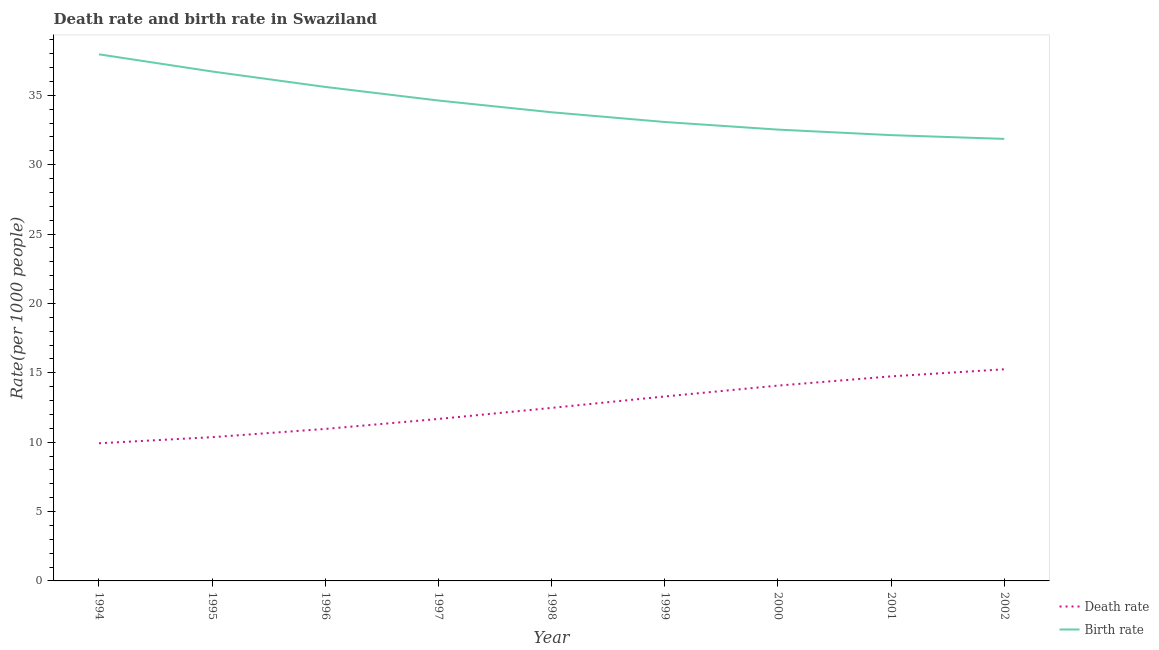How many different coloured lines are there?
Keep it short and to the point. 2. What is the death rate in 2002?
Offer a very short reply. 15.25. Across all years, what is the maximum birth rate?
Keep it short and to the point. 37.95. Across all years, what is the minimum birth rate?
Your answer should be very brief. 31.86. In which year was the birth rate maximum?
Your answer should be compact. 1994. In which year was the birth rate minimum?
Your response must be concise. 2002. What is the total birth rate in the graph?
Make the answer very short. 308.24. What is the difference between the death rate in 1996 and that in 1997?
Your response must be concise. -0.72. What is the difference between the death rate in 1996 and the birth rate in 1995?
Offer a very short reply. -25.76. What is the average death rate per year?
Offer a terse response. 12.53. In the year 1996, what is the difference between the birth rate and death rate?
Keep it short and to the point. 24.65. What is the ratio of the death rate in 1996 to that in 1998?
Your answer should be compact. 0.88. Is the difference between the birth rate in 1995 and 1997 greater than the difference between the death rate in 1995 and 1997?
Make the answer very short. Yes. What is the difference between the highest and the second highest death rate?
Offer a very short reply. 0.51. What is the difference between the highest and the lowest birth rate?
Your answer should be very brief. 6.09. Is the birth rate strictly greater than the death rate over the years?
Offer a very short reply. Yes. How many lines are there?
Keep it short and to the point. 2. Are the values on the major ticks of Y-axis written in scientific E-notation?
Provide a succinct answer. No. How many legend labels are there?
Give a very brief answer. 2. What is the title of the graph?
Your answer should be compact. Death rate and birth rate in Swaziland. What is the label or title of the Y-axis?
Offer a terse response. Rate(per 1000 people). What is the Rate(per 1000 people) of Death rate in 1994?
Your answer should be compact. 9.92. What is the Rate(per 1000 people) of Birth rate in 1994?
Ensure brevity in your answer.  37.95. What is the Rate(per 1000 people) in Death rate in 1995?
Ensure brevity in your answer.  10.36. What is the Rate(per 1000 people) of Birth rate in 1995?
Offer a very short reply. 36.71. What is the Rate(per 1000 people) of Death rate in 1996?
Ensure brevity in your answer.  10.95. What is the Rate(per 1000 people) in Birth rate in 1996?
Give a very brief answer. 35.6. What is the Rate(per 1000 people) of Death rate in 1997?
Provide a short and direct response. 11.67. What is the Rate(per 1000 people) in Birth rate in 1997?
Your response must be concise. 34.62. What is the Rate(per 1000 people) in Death rate in 1998?
Offer a terse response. 12.47. What is the Rate(per 1000 people) in Birth rate in 1998?
Provide a short and direct response. 33.77. What is the Rate(per 1000 people) in Death rate in 1999?
Provide a short and direct response. 13.29. What is the Rate(per 1000 people) in Birth rate in 1999?
Keep it short and to the point. 33.07. What is the Rate(per 1000 people) in Death rate in 2000?
Make the answer very short. 14.08. What is the Rate(per 1000 people) of Birth rate in 2000?
Ensure brevity in your answer.  32.52. What is the Rate(per 1000 people) in Death rate in 2001?
Make the answer very short. 14.74. What is the Rate(per 1000 people) in Birth rate in 2001?
Provide a short and direct response. 32.13. What is the Rate(per 1000 people) of Death rate in 2002?
Your response must be concise. 15.25. What is the Rate(per 1000 people) of Birth rate in 2002?
Your answer should be very brief. 31.86. Across all years, what is the maximum Rate(per 1000 people) of Death rate?
Make the answer very short. 15.25. Across all years, what is the maximum Rate(per 1000 people) of Birth rate?
Provide a succinct answer. 37.95. Across all years, what is the minimum Rate(per 1000 people) of Death rate?
Your response must be concise. 9.92. Across all years, what is the minimum Rate(per 1000 people) in Birth rate?
Offer a terse response. 31.86. What is the total Rate(per 1000 people) in Death rate in the graph?
Give a very brief answer. 112.74. What is the total Rate(per 1000 people) of Birth rate in the graph?
Offer a terse response. 308.24. What is the difference between the Rate(per 1000 people) of Death rate in 1994 and that in 1995?
Provide a succinct answer. -0.44. What is the difference between the Rate(per 1000 people) in Birth rate in 1994 and that in 1995?
Offer a terse response. 1.24. What is the difference between the Rate(per 1000 people) of Death rate in 1994 and that in 1996?
Give a very brief answer. -1.03. What is the difference between the Rate(per 1000 people) in Birth rate in 1994 and that in 1996?
Keep it short and to the point. 2.35. What is the difference between the Rate(per 1000 people) in Death rate in 1994 and that in 1997?
Give a very brief answer. -1.75. What is the difference between the Rate(per 1000 people) in Birth rate in 1994 and that in 1997?
Your response must be concise. 3.33. What is the difference between the Rate(per 1000 people) in Death rate in 1994 and that in 1998?
Keep it short and to the point. -2.55. What is the difference between the Rate(per 1000 people) in Birth rate in 1994 and that in 1998?
Give a very brief answer. 4.18. What is the difference between the Rate(per 1000 people) in Death rate in 1994 and that in 1999?
Ensure brevity in your answer.  -3.37. What is the difference between the Rate(per 1000 people) in Birth rate in 1994 and that in 1999?
Give a very brief answer. 4.88. What is the difference between the Rate(per 1000 people) of Death rate in 1994 and that in 2000?
Offer a very short reply. -4.16. What is the difference between the Rate(per 1000 people) of Birth rate in 1994 and that in 2000?
Your answer should be compact. 5.43. What is the difference between the Rate(per 1000 people) of Death rate in 1994 and that in 2001?
Provide a succinct answer. -4.82. What is the difference between the Rate(per 1000 people) in Birth rate in 1994 and that in 2001?
Your answer should be very brief. 5.82. What is the difference between the Rate(per 1000 people) in Death rate in 1994 and that in 2002?
Make the answer very short. -5.33. What is the difference between the Rate(per 1000 people) in Birth rate in 1994 and that in 2002?
Give a very brief answer. 6.09. What is the difference between the Rate(per 1000 people) in Death rate in 1995 and that in 1996?
Make the answer very short. -0.59. What is the difference between the Rate(per 1000 people) in Birth rate in 1995 and that in 1996?
Your answer should be compact. 1.11. What is the difference between the Rate(per 1000 people) of Death rate in 1995 and that in 1997?
Your response must be concise. -1.31. What is the difference between the Rate(per 1000 people) of Birth rate in 1995 and that in 1997?
Offer a terse response. 2.09. What is the difference between the Rate(per 1000 people) of Death rate in 1995 and that in 1998?
Ensure brevity in your answer.  -2.11. What is the difference between the Rate(per 1000 people) in Birth rate in 1995 and that in 1998?
Your answer should be compact. 2.94. What is the difference between the Rate(per 1000 people) in Death rate in 1995 and that in 1999?
Offer a terse response. -2.94. What is the difference between the Rate(per 1000 people) of Birth rate in 1995 and that in 1999?
Keep it short and to the point. 3.64. What is the difference between the Rate(per 1000 people) in Death rate in 1995 and that in 2000?
Provide a succinct answer. -3.72. What is the difference between the Rate(per 1000 people) of Birth rate in 1995 and that in 2000?
Your answer should be very brief. 4.19. What is the difference between the Rate(per 1000 people) in Death rate in 1995 and that in 2001?
Provide a short and direct response. -4.38. What is the difference between the Rate(per 1000 people) of Birth rate in 1995 and that in 2001?
Keep it short and to the point. 4.58. What is the difference between the Rate(per 1000 people) in Death rate in 1995 and that in 2002?
Ensure brevity in your answer.  -4.89. What is the difference between the Rate(per 1000 people) in Birth rate in 1995 and that in 2002?
Your answer should be compact. 4.86. What is the difference between the Rate(per 1000 people) in Death rate in 1996 and that in 1997?
Offer a very short reply. -0.72. What is the difference between the Rate(per 1000 people) of Birth rate in 1996 and that in 1997?
Offer a very short reply. 0.98. What is the difference between the Rate(per 1000 people) in Death rate in 1996 and that in 1998?
Provide a short and direct response. -1.52. What is the difference between the Rate(per 1000 people) of Birth rate in 1996 and that in 1998?
Your answer should be compact. 1.83. What is the difference between the Rate(per 1000 people) in Death rate in 1996 and that in 1999?
Provide a succinct answer. -2.34. What is the difference between the Rate(per 1000 people) of Birth rate in 1996 and that in 1999?
Make the answer very short. 2.53. What is the difference between the Rate(per 1000 people) in Death rate in 1996 and that in 2000?
Keep it short and to the point. -3.12. What is the difference between the Rate(per 1000 people) of Birth rate in 1996 and that in 2000?
Give a very brief answer. 3.08. What is the difference between the Rate(per 1000 people) of Death rate in 1996 and that in 2001?
Make the answer very short. -3.79. What is the difference between the Rate(per 1000 people) in Birth rate in 1996 and that in 2001?
Give a very brief answer. 3.47. What is the difference between the Rate(per 1000 people) in Death rate in 1996 and that in 2002?
Make the answer very short. -4.3. What is the difference between the Rate(per 1000 people) of Birth rate in 1996 and that in 2002?
Offer a terse response. 3.75. What is the difference between the Rate(per 1000 people) of Death rate in 1997 and that in 1998?
Keep it short and to the point. -0.8. What is the difference between the Rate(per 1000 people) in Birth rate in 1997 and that in 1998?
Keep it short and to the point. 0.85. What is the difference between the Rate(per 1000 people) of Death rate in 1997 and that in 1999?
Your response must be concise. -1.62. What is the difference between the Rate(per 1000 people) of Birth rate in 1997 and that in 1999?
Your answer should be very brief. 1.55. What is the difference between the Rate(per 1000 people) in Death rate in 1997 and that in 2000?
Offer a terse response. -2.4. What is the difference between the Rate(per 1000 people) in Birth rate in 1997 and that in 2000?
Your answer should be compact. 2.1. What is the difference between the Rate(per 1000 people) of Death rate in 1997 and that in 2001?
Your answer should be very brief. -3.07. What is the difference between the Rate(per 1000 people) of Birth rate in 1997 and that in 2001?
Your answer should be compact. 2.49. What is the difference between the Rate(per 1000 people) of Death rate in 1997 and that in 2002?
Ensure brevity in your answer.  -3.58. What is the difference between the Rate(per 1000 people) in Birth rate in 1997 and that in 2002?
Your answer should be very brief. 2.77. What is the difference between the Rate(per 1000 people) in Death rate in 1998 and that in 1999?
Ensure brevity in your answer.  -0.82. What is the difference between the Rate(per 1000 people) of Birth rate in 1998 and that in 1999?
Your response must be concise. 0.7. What is the difference between the Rate(per 1000 people) in Death rate in 1998 and that in 2000?
Provide a succinct answer. -1.61. What is the difference between the Rate(per 1000 people) of Death rate in 1998 and that in 2001?
Give a very brief answer. -2.27. What is the difference between the Rate(per 1000 people) in Birth rate in 1998 and that in 2001?
Offer a very short reply. 1.65. What is the difference between the Rate(per 1000 people) of Death rate in 1998 and that in 2002?
Make the answer very short. -2.78. What is the difference between the Rate(per 1000 people) of Birth rate in 1998 and that in 2002?
Offer a very short reply. 1.92. What is the difference between the Rate(per 1000 people) in Death rate in 1999 and that in 2000?
Your response must be concise. -0.78. What is the difference between the Rate(per 1000 people) in Birth rate in 1999 and that in 2000?
Ensure brevity in your answer.  0.55. What is the difference between the Rate(per 1000 people) of Death rate in 1999 and that in 2001?
Your response must be concise. -1.45. What is the difference between the Rate(per 1000 people) of Birth rate in 1999 and that in 2001?
Offer a very short reply. 0.95. What is the difference between the Rate(per 1000 people) of Death rate in 1999 and that in 2002?
Offer a terse response. -1.96. What is the difference between the Rate(per 1000 people) of Birth rate in 1999 and that in 2002?
Your answer should be compact. 1.22. What is the difference between the Rate(per 1000 people) in Death rate in 2000 and that in 2001?
Your response must be concise. -0.67. What is the difference between the Rate(per 1000 people) of Birth rate in 2000 and that in 2001?
Your answer should be very brief. 0.4. What is the difference between the Rate(per 1000 people) in Death rate in 2000 and that in 2002?
Provide a short and direct response. -1.18. What is the difference between the Rate(per 1000 people) of Birth rate in 2000 and that in 2002?
Provide a succinct answer. 0.67. What is the difference between the Rate(per 1000 people) in Death rate in 2001 and that in 2002?
Keep it short and to the point. -0.51. What is the difference between the Rate(per 1000 people) of Birth rate in 2001 and that in 2002?
Make the answer very short. 0.27. What is the difference between the Rate(per 1000 people) in Death rate in 1994 and the Rate(per 1000 people) in Birth rate in 1995?
Give a very brief answer. -26.79. What is the difference between the Rate(per 1000 people) in Death rate in 1994 and the Rate(per 1000 people) in Birth rate in 1996?
Give a very brief answer. -25.68. What is the difference between the Rate(per 1000 people) in Death rate in 1994 and the Rate(per 1000 people) in Birth rate in 1997?
Your answer should be very brief. -24.7. What is the difference between the Rate(per 1000 people) of Death rate in 1994 and the Rate(per 1000 people) of Birth rate in 1998?
Keep it short and to the point. -23.85. What is the difference between the Rate(per 1000 people) of Death rate in 1994 and the Rate(per 1000 people) of Birth rate in 1999?
Offer a terse response. -23.15. What is the difference between the Rate(per 1000 people) of Death rate in 1994 and the Rate(per 1000 people) of Birth rate in 2000?
Your answer should be very brief. -22.6. What is the difference between the Rate(per 1000 people) of Death rate in 1994 and the Rate(per 1000 people) of Birth rate in 2001?
Offer a terse response. -22.21. What is the difference between the Rate(per 1000 people) of Death rate in 1994 and the Rate(per 1000 people) of Birth rate in 2002?
Give a very brief answer. -21.93. What is the difference between the Rate(per 1000 people) in Death rate in 1995 and the Rate(per 1000 people) in Birth rate in 1996?
Ensure brevity in your answer.  -25.24. What is the difference between the Rate(per 1000 people) of Death rate in 1995 and the Rate(per 1000 people) of Birth rate in 1997?
Provide a succinct answer. -24.26. What is the difference between the Rate(per 1000 people) of Death rate in 1995 and the Rate(per 1000 people) of Birth rate in 1998?
Provide a succinct answer. -23.42. What is the difference between the Rate(per 1000 people) in Death rate in 1995 and the Rate(per 1000 people) in Birth rate in 1999?
Keep it short and to the point. -22.71. What is the difference between the Rate(per 1000 people) in Death rate in 1995 and the Rate(per 1000 people) in Birth rate in 2000?
Provide a succinct answer. -22.17. What is the difference between the Rate(per 1000 people) of Death rate in 1995 and the Rate(per 1000 people) of Birth rate in 2001?
Your answer should be very brief. -21.77. What is the difference between the Rate(per 1000 people) of Death rate in 1995 and the Rate(per 1000 people) of Birth rate in 2002?
Ensure brevity in your answer.  -21.5. What is the difference between the Rate(per 1000 people) of Death rate in 1996 and the Rate(per 1000 people) of Birth rate in 1997?
Your answer should be very brief. -23.67. What is the difference between the Rate(per 1000 people) of Death rate in 1996 and the Rate(per 1000 people) of Birth rate in 1998?
Offer a very short reply. -22.82. What is the difference between the Rate(per 1000 people) of Death rate in 1996 and the Rate(per 1000 people) of Birth rate in 1999?
Your response must be concise. -22.12. What is the difference between the Rate(per 1000 people) in Death rate in 1996 and the Rate(per 1000 people) in Birth rate in 2000?
Provide a short and direct response. -21.57. What is the difference between the Rate(per 1000 people) of Death rate in 1996 and the Rate(per 1000 people) of Birth rate in 2001?
Offer a terse response. -21.17. What is the difference between the Rate(per 1000 people) of Death rate in 1996 and the Rate(per 1000 people) of Birth rate in 2002?
Provide a succinct answer. -20.9. What is the difference between the Rate(per 1000 people) in Death rate in 1997 and the Rate(per 1000 people) in Birth rate in 1998?
Offer a terse response. -22.1. What is the difference between the Rate(per 1000 people) of Death rate in 1997 and the Rate(per 1000 people) of Birth rate in 1999?
Your answer should be very brief. -21.4. What is the difference between the Rate(per 1000 people) in Death rate in 1997 and the Rate(per 1000 people) in Birth rate in 2000?
Make the answer very short. -20.85. What is the difference between the Rate(per 1000 people) of Death rate in 1997 and the Rate(per 1000 people) of Birth rate in 2001?
Keep it short and to the point. -20.45. What is the difference between the Rate(per 1000 people) of Death rate in 1997 and the Rate(per 1000 people) of Birth rate in 2002?
Offer a terse response. -20.18. What is the difference between the Rate(per 1000 people) in Death rate in 1998 and the Rate(per 1000 people) in Birth rate in 1999?
Your answer should be very brief. -20.6. What is the difference between the Rate(per 1000 people) in Death rate in 1998 and the Rate(per 1000 people) in Birth rate in 2000?
Offer a very short reply. -20.05. What is the difference between the Rate(per 1000 people) in Death rate in 1998 and the Rate(per 1000 people) in Birth rate in 2001?
Offer a very short reply. -19.66. What is the difference between the Rate(per 1000 people) in Death rate in 1998 and the Rate(per 1000 people) in Birth rate in 2002?
Your answer should be compact. -19.39. What is the difference between the Rate(per 1000 people) of Death rate in 1999 and the Rate(per 1000 people) of Birth rate in 2000?
Offer a terse response. -19.23. What is the difference between the Rate(per 1000 people) of Death rate in 1999 and the Rate(per 1000 people) of Birth rate in 2001?
Provide a succinct answer. -18.83. What is the difference between the Rate(per 1000 people) in Death rate in 1999 and the Rate(per 1000 people) in Birth rate in 2002?
Make the answer very short. -18.56. What is the difference between the Rate(per 1000 people) in Death rate in 2000 and the Rate(per 1000 people) in Birth rate in 2001?
Offer a very short reply. -18.05. What is the difference between the Rate(per 1000 people) of Death rate in 2000 and the Rate(per 1000 people) of Birth rate in 2002?
Ensure brevity in your answer.  -17.78. What is the difference between the Rate(per 1000 people) in Death rate in 2001 and the Rate(per 1000 people) in Birth rate in 2002?
Your answer should be very brief. -17.11. What is the average Rate(per 1000 people) of Death rate per year?
Provide a succinct answer. 12.53. What is the average Rate(per 1000 people) of Birth rate per year?
Keep it short and to the point. 34.25. In the year 1994, what is the difference between the Rate(per 1000 people) in Death rate and Rate(per 1000 people) in Birth rate?
Your answer should be very brief. -28.03. In the year 1995, what is the difference between the Rate(per 1000 people) in Death rate and Rate(per 1000 people) in Birth rate?
Offer a terse response. -26.35. In the year 1996, what is the difference between the Rate(per 1000 people) in Death rate and Rate(per 1000 people) in Birth rate?
Provide a short and direct response. -24.65. In the year 1997, what is the difference between the Rate(per 1000 people) in Death rate and Rate(per 1000 people) in Birth rate?
Provide a short and direct response. -22.95. In the year 1998, what is the difference between the Rate(per 1000 people) in Death rate and Rate(per 1000 people) in Birth rate?
Keep it short and to the point. -21.3. In the year 1999, what is the difference between the Rate(per 1000 people) of Death rate and Rate(per 1000 people) of Birth rate?
Your answer should be very brief. -19.78. In the year 2000, what is the difference between the Rate(per 1000 people) of Death rate and Rate(per 1000 people) of Birth rate?
Offer a terse response. -18.45. In the year 2001, what is the difference between the Rate(per 1000 people) of Death rate and Rate(per 1000 people) of Birth rate?
Offer a terse response. -17.39. In the year 2002, what is the difference between the Rate(per 1000 people) of Death rate and Rate(per 1000 people) of Birth rate?
Your answer should be compact. -16.6. What is the ratio of the Rate(per 1000 people) of Death rate in 1994 to that in 1995?
Provide a short and direct response. 0.96. What is the ratio of the Rate(per 1000 people) in Birth rate in 1994 to that in 1995?
Keep it short and to the point. 1.03. What is the ratio of the Rate(per 1000 people) in Death rate in 1994 to that in 1996?
Provide a succinct answer. 0.91. What is the ratio of the Rate(per 1000 people) of Birth rate in 1994 to that in 1996?
Provide a short and direct response. 1.07. What is the ratio of the Rate(per 1000 people) of Death rate in 1994 to that in 1997?
Offer a very short reply. 0.85. What is the ratio of the Rate(per 1000 people) of Birth rate in 1994 to that in 1997?
Your answer should be compact. 1.1. What is the ratio of the Rate(per 1000 people) in Death rate in 1994 to that in 1998?
Keep it short and to the point. 0.8. What is the ratio of the Rate(per 1000 people) in Birth rate in 1994 to that in 1998?
Your response must be concise. 1.12. What is the ratio of the Rate(per 1000 people) of Death rate in 1994 to that in 1999?
Give a very brief answer. 0.75. What is the ratio of the Rate(per 1000 people) in Birth rate in 1994 to that in 1999?
Your answer should be very brief. 1.15. What is the ratio of the Rate(per 1000 people) in Death rate in 1994 to that in 2000?
Offer a very short reply. 0.7. What is the ratio of the Rate(per 1000 people) in Birth rate in 1994 to that in 2000?
Offer a terse response. 1.17. What is the ratio of the Rate(per 1000 people) in Death rate in 1994 to that in 2001?
Offer a very short reply. 0.67. What is the ratio of the Rate(per 1000 people) in Birth rate in 1994 to that in 2001?
Your answer should be compact. 1.18. What is the ratio of the Rate(per 1000 people) in Death rate in 1994 to that in 2002?
Provide a short and direct response. 0.65. What is the ratio of the Rate(per 1000 people) of Birth rate in 1994 to that in 2002?
Provide a succinct answer. 1.19. What is the ratio of the Rate(per 1000 people) in Death rate in 1995 to that in 1996?
Your answer should be compact. 0.95. What is the ratio of the Rate(per 1000 people) of Birth rate in 1995 to that in 1996?
Keep it short and to the point. 1.03. What is the ratio of the Rate(per 1000 people) in Death rate in 1995 to that in 1997?
Ensure brevity in your answer.  0.89. What is the ratio of the Rate(per 1000 people) in Birth rate in 1995 to that in 1997?
Ensure brevity in your answer.  1.06. What is the ratio of the Rate(per 1000 people) of Death rate in 1995 to that in 1998?
Your answer should be very brief. 0.83. What is the ratio of the Rate(per 1000 people) of Birth rate in 1995 to that in 1998?
Ensure brevity in your answer.  1.09. What is the ratio of the Rate(per 1000 people) of Death rate in 1995 to that in 1999?
Make the answer very short. 0.78. What is the ratio of the Rate(per 1000 people) in Birth rate in 1995 to that in 1999?
Offer a terse response. 1.11. What is the ratio of the Rate(per 1000 people) in Death rate in 1995 to that in 2000?
Offer a very short reply. 0.74. What is the ratio of the Rate(per 1000 people) of Birth rate in 1995 to that in 2000?
Provide a succinct answer. 1.13. What is the ratio of the Rate(per 1000 people) of Death rate in 1995 to that in 2001?
Offer a terse response. 0.7. What is the ratio of the Rate(per 1000 people) of Birth rate in 1995 to that in 2001?
Make the answer very short. 1.14. What is the ratio of the Rate(per 1000 people) in Death rate in 1995 to that in 2002?
Provide a succinct answer. 0.68. What is the ratio of the Rate(per 1000 people) in Birth rate in 1995 to that in 2002?
Your answer should be compact. 1.15. What is the ratio of the Rate(per 1000 people) of Death rate in 1996 to that in 1997?
Keep it short and to the point. 0.94. What is the ratio of the Rate(per 1000 people) in Birth rate in 1996 to that in 1997?
Make the answer very short. 1.03. What is the ratio of the Rate(per 1000 people) of Death rate in 1996 to that in 1998?
Your answer should be compact. 0.88. What is the ratio of the Rate(per 1000 people) of Birth rate in 1996 to that in 1998?
Give a very brief answer. 1.05. What is the ratio of the Rate(per 1000 people) in Death rate in 1996 to that in 1999?
Your response must be concise. 0.82. What is the ratio of the Rate(per 1000 people) of Birth rate in 1996 to that in 1999?
Offer a terse response. 1.08. What is the ratio of the Rate(per 1000 people) in Death rate in 1996 to that in 2000?
Offer a very short reply. 0.78. What is the ratio of the Rate(per 1000 people) of Birth rate in 1996 to that in 2000?
Your response must be concise. 1.09. What is the ratio of the Rate(per 1000 people) in Death rate in 1996 to that in 2001?
Your response must be concise. 0.74. What is the ratio of the Rate(per 1000 people) in Birth rate in 1996 to that in 2001?
Give a very brief answer. 1.11. What is the ratio of the Rate(per 1000 people) of Death rate in 1996 to that in 2002?
Ensure brevity in your answer.  0.72. What is the ratio of the Rate(per 1000 people) in Birth rate in 1996 to that in 2002?
Provide a succinct answer. 1.12. What is the ratio of the Rate(per 1000 people) in Death rate in 1997 to that in 1998?
Your answer should be compact. 0.94. What is the ratio of the Rate(per 1000 people) of Birth rate in 1997 to that in 1998?
Your answer should be compact. 1.02. What is the ratio of the Rate(per 1000 people) of Death rate in 1997 to that in 1999?
Offer a very short reply. 0.88. What is the ratio of the Rate(per 1000 people) in Birth rate in 1997 to that in 1999?
Your answer should be compact. 1.05. What is the ratio of the Rate(per 1000 people) in Death rate in 1997 to that in 2000?
Your answer should be compact. 0.83. What is the ratio of the Rate(per 1000 people) of Birth rate in 1997 to that in 2000?
Your answer should be compact. 1.06. What is the ratio of the Rate(per 1000 people) in Death rate in 1997 to that in 2001?
Ensure brevity in your answer.  0.79. What is the ratio of the Rate(per 1000 people) in Birth rate in 1997 to that in 2001?
Keep it short and to the point. 1.08. What is the ratio of the Rate(per 1000 people) in Death rate in 1997 to that in 2002?
Offer a very short reply. 0.77. What is the ratio of the Rate(per 1000 people) in Birth rate in 1997 to that in 2002?
Offer a very short reply. 1.09. What is the ratio of the Rate(per 1000 people) in Death rate in 1998 to that in 1999?
Make the answer very short. 0.94. What is the ratio of the Rate(per 1000 people) in Birth rate in 1998 to that in 1999?
Offer a terse response. 1.02. What is the ratio of the Rate(per 1000 people) in Death rate in 1998 to that in 2000?
Your answer should be compact. 0.89. What is the ratio of the Rate(per 1000 people) of Birth rate in 1998 to that in 2000?
Your answer should be very brief. 1.04. What is the ratio of the Rate(per 1000 people) of Death rate in 1998 to that in 2001?
Your answer should be very brief. 0.85. What is the ratio of the Rate(per 1000 people) in Birth rate in 1998 to that in 2001?
Provide a succinct answer. 1.05. What is the ratio of the Rate(per 1000 people) in Death rate in 1998 to that in 2002?
Your answer should be very brief. 0.82. What is the ratio of the Rate(per 1000 people) of Birth rate in 1998 to that in 2002?
Give a very brief answer. 1.06. What is the ratio of the Rate(per 1000 people) of Birth rate in 1999 to that in 2000?
Make the answer very short. 1.02. What is the ratio of the Rate(per 1000 people) of Death rate in 1999 to that in 2001?
Provide a succinct answer. 0.9. What is the ratio of the Rate(per 1000 people) in Birth rate in 1999 to that in 2001?
Offer a very short reply. 1.03. What is the ratio of the Rate(per 1000 people) in Death rate in 1999 to that in 2002?
Provide a succinct answer. 0.87. What is the ratio of the Rate(per 1000 people) of Birth rate in 1999 to that in 2002?
Your answer should be very brief. 1.04. What is the ratio of the Rate(per 1000 people) in Death rate in 2000 to that in 2001?
Provide a short and direct response. 0.95. What is the ratio of the Rate(per 1000 people) in Birth rate in 2000 to that in 2001?
Provide a short and direct response. 1.01. What is the ratio of the Rate(per 1000 people) of Death rate in 2000 to that in 2002?
Ensure brevity in your answer.  0.92. What is the ratio of the Rate(per 1000 people) of Birth rate in 2000 to that in 2002?
Ensure brevity in your answer.  1.02. What is the ratio of the Rate(per 1000 people) of Death rate in 2001 to that in 2002?
Keep it short and to the point. 0.97. What is the ratio of the Rate(per 1000 people) of Birth rate in 2001 to that in 2002?
Keep it short and to the point. 1.01. What is the difference between the highest and the second highest Rate(per 1000 people) in Death rate?
Your answer should be compact. 0.51. What is the difference between the highest and the second highest Rate(per 1000 people) of Birth rate?
Ensure brevity in your answer.  1.24. What is the difference between the highest and the lowest Rate(per 1000 people) in Death rate?
Keep it short and to the point. 5.33. What is the difference between the highest and the lowest Rate(per 1000 people) of Birth rate?
Keep it short and to the point. 6.09. 